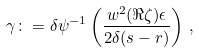Convert formula to latex. <formula><loc_0><loc_0><loc_500><loc_500>\gamma \colon = \delta \psi ^ { - 1 } \left ( \frac { w ^ { 2 } ( \Re \zeta ) \epsilon } { 2 \delta ( s - r ) } \right ) \, ,</formula> 